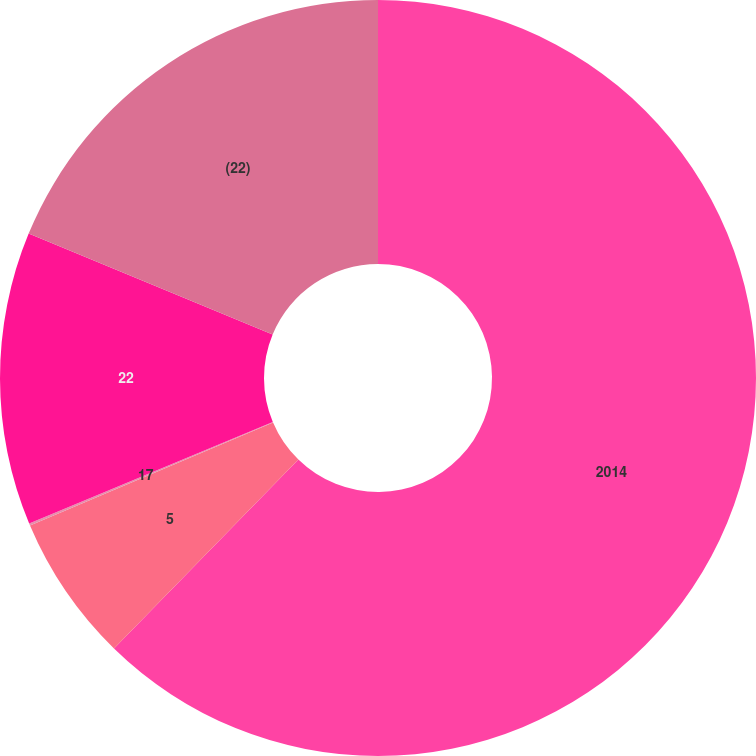Convert chart. <chart><loc_0><loc_0><loc_500><loc_500><pie_chart><fcel>2014<fcel>5<fcel>17<fcel>22<fcel>(22)<nl><fcel>62.3%<fcel>6.31%<fcel>0.09%<fcel>12.53%<fcel>18.76%<nl></chart> 